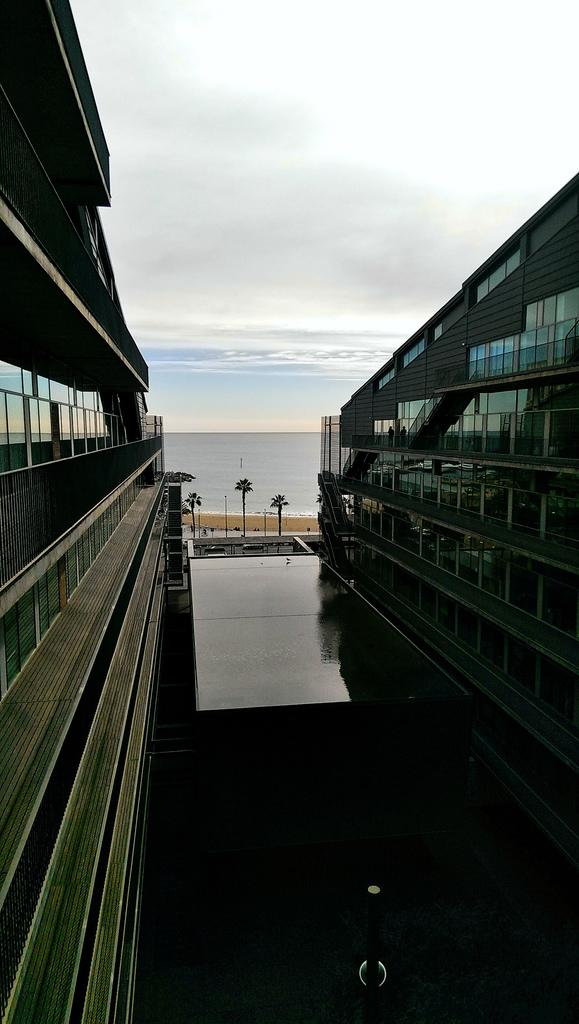What is located on the right side of the image? There are buildings on the right side of the image. What is located on the left side of the image? There are buildings on the left side of the image. What can be seen in the center of the image? There is water and trees in the center of the image. What is visible in the background of the image? There are clouds, water, and the sky visible in the background of the image. How many parcels are floating in the water in the image? There are no parcels present in the image; it features buildings, trees, water, clouds, and the sky. What is the chance of rain in the image? The image does not provide any information about the weather or the chance of rain. 